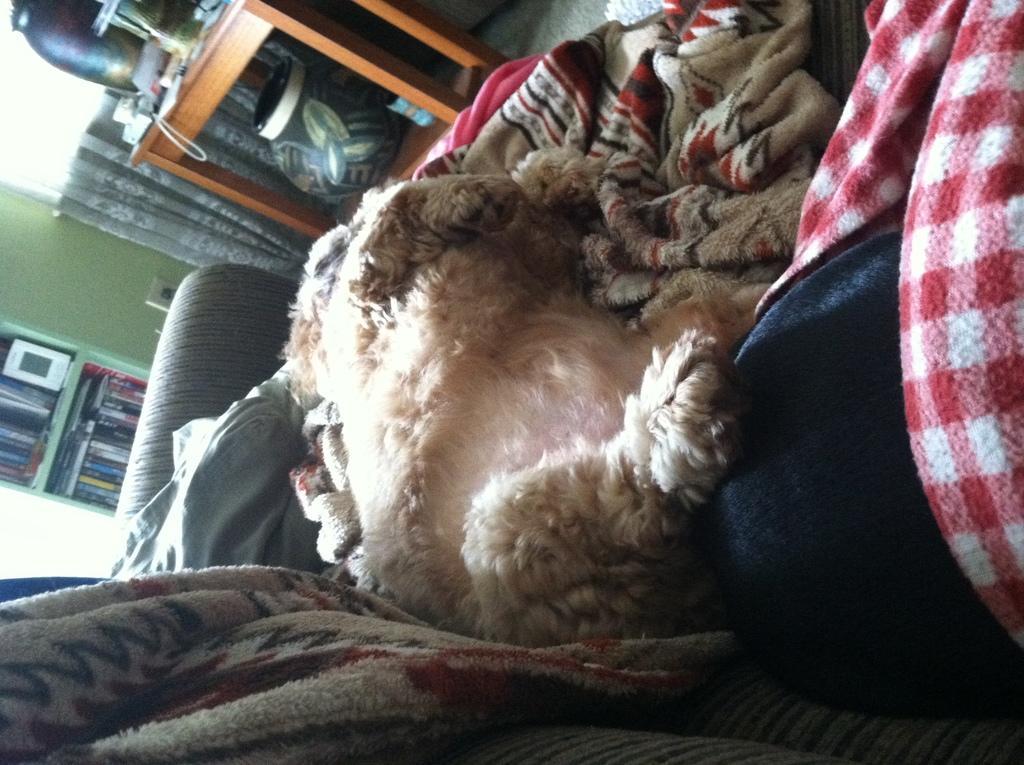Please provide a concise description of this image. In this picture I can see some clothes and an animal on the sofa. In the background I can see a window and curtain. On the left side i can see wooden table on which I can see some objects on it. I can also see a shelf which has books. 